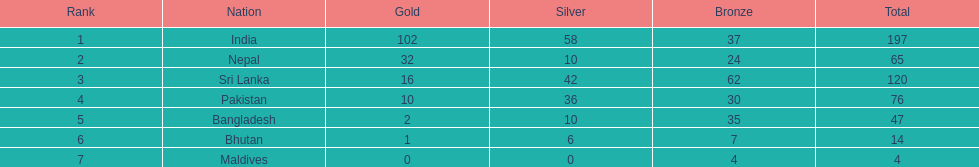I'm looking to parse the entire table for insights. Could you assist me with that? {'header': ['Rank', 'Nation', 'Gold', 'Silver', 'Bronze', 'Total'], 'rows': [['1', 'India', '102', '58', '37', '197'], ['2', 'Nepal', '32', '10', '24', '65'], ['3', 'Sri Lanka', '16', '42', '62', '120'], ['4', 'Pakistan', '10', '36', '30', '76'], ['5', 'Bangladesh', '2', '10', '35', '47'], ['6', 'Bhutan', '1', '6', '7', '14'], ['7', 'Maldives', '0', '0', '4', '4']]} What country has achieved no silver medals? Maldives. 